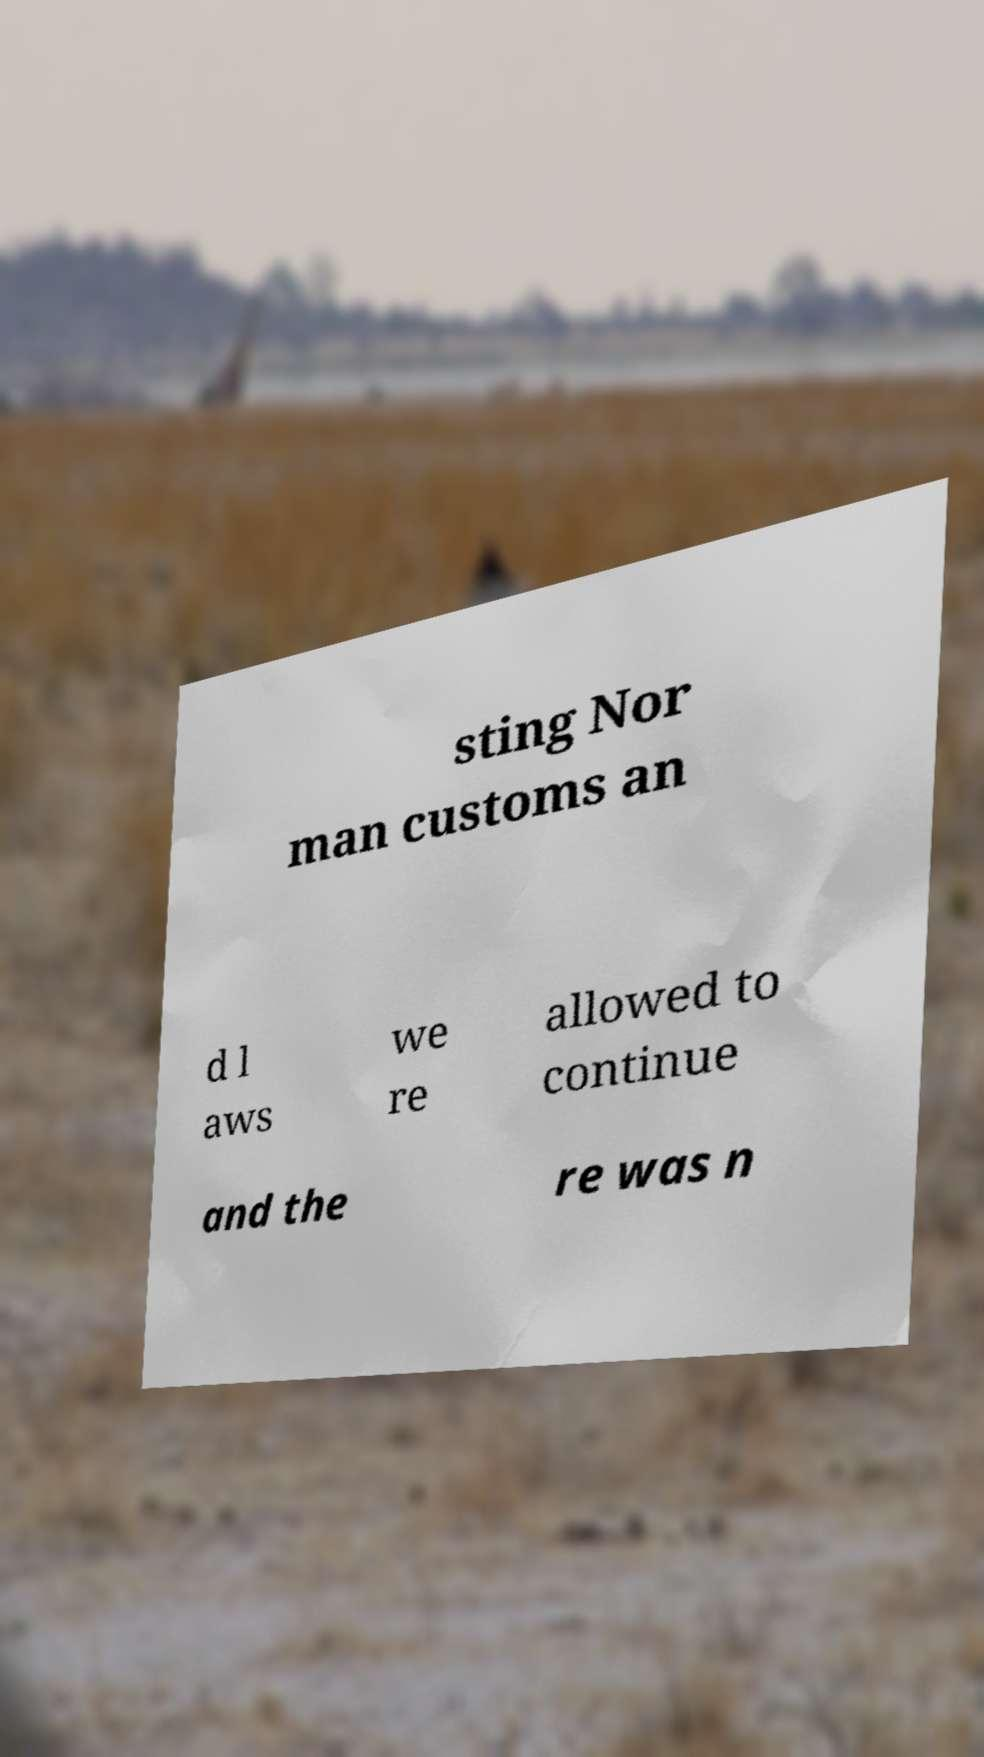Can you read and provide the text displayed in the image?This photo seems to have some interesting text. Can you extract and type it out for me? sting Nor man customs an d l aws we re allowed to continue and the re was n 